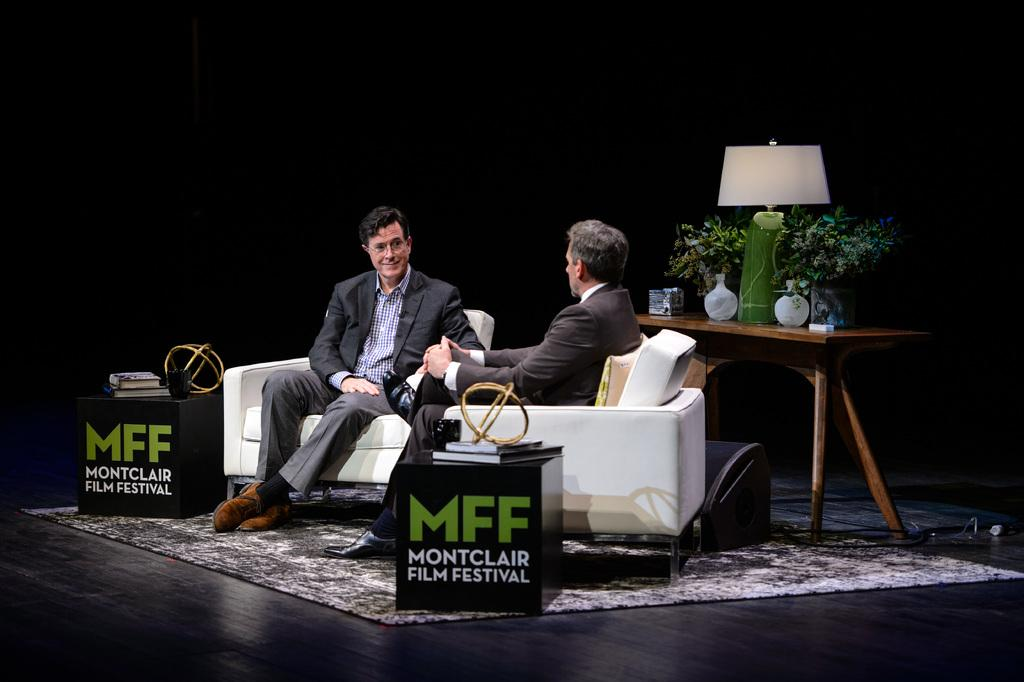How many people are in the image? There are two people in the image. What are the two people doing in the image? The two people are sitting on chairs. What is the limit of the voice in the image? There is no mention of a voice or a limit in the image. What suggestion can be made based on the image? The image does not provide enough information to make a specific suggestion. 